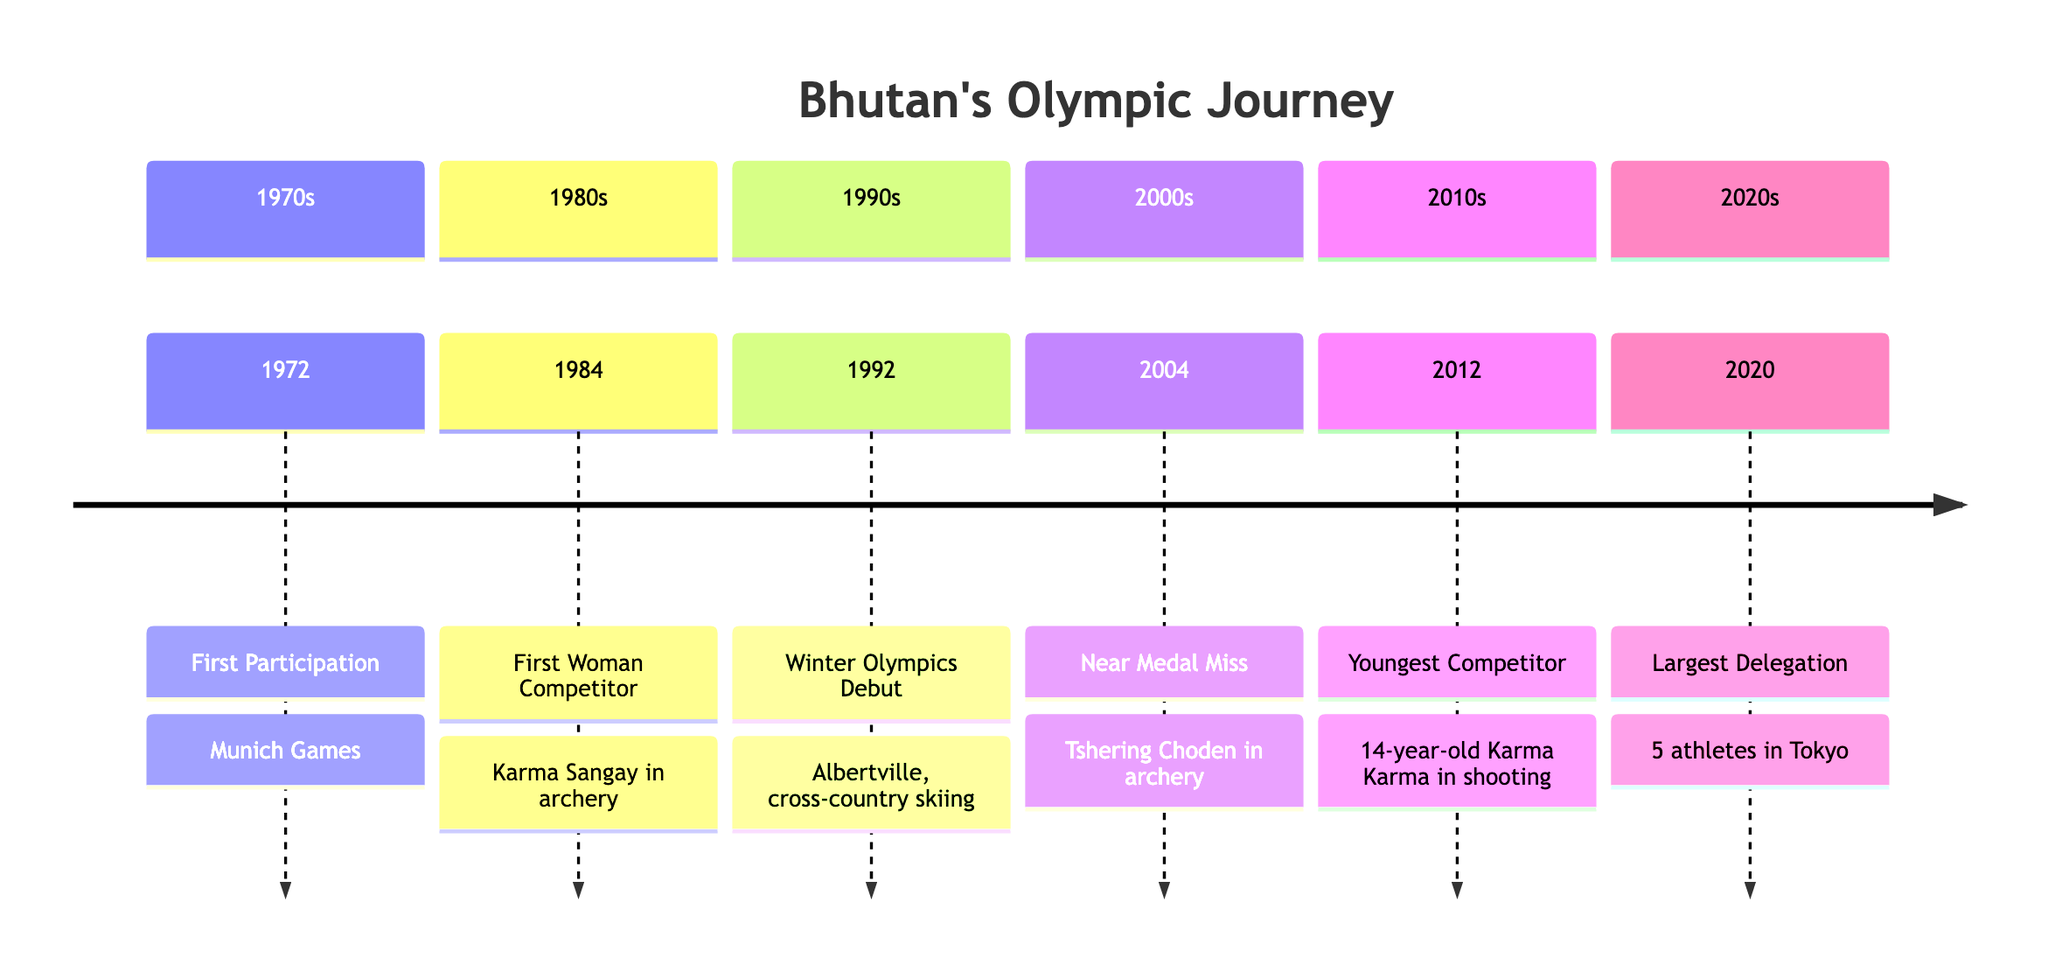what year did Bhutan first participate in the Olympics? The timeline indicates that Bhutan's first participation in the Olympics was in 1972 during the Munich Games.
Answer: 1972 who was Bhutan's first female competitor in the Olympics? The timeline states that Karma Sangay was Bhutan's first female competitor, who participated in archery during the Los Angeles Olympics in 1984.
Answer: Karma Sangay in which year did Bhutan debut at the Winter Olympics? The timeline shows that Bhutan made its debut in the Winter Olympics in 1992 at Albertville.
Answer: 1992 how many athletes represented Bhutan at the 2020 Tokyo Olympics? According to the timeline, Bhutan sent five athletes to compete in various sports during the Tokyo Olympics in 2020.
Answer: 5 what notable event occurred for Bhutan in the year 2004? The timeline highlights that in 2004, Tshering Choden, an archer, reached the quarter-finals in Athens, which was Bhutan's first Olympic medal near miss.
Answer: First Olympic Medal Near Miss which year marked the participation of Bhutan's youngest competitor? The timeline indicates that the youngest competitor for Bhutan, 14-year-old Karma Karma, participated in the shooting event during the London Olympics in 2012.
Answer: 2012 what sport did Bhutan's first female competitor participate in? The timeline details that Bhutan's first female competitor, Karma Sangay, competed in archery during the Los Angeles Olympics in 1984.
Answer: Archery what is the significance of the year 2020 in Bhutan's Olympic journey? The timeline states that in 2020, Bhutan sent its largest delegation of five athletes to the Tokyo Olympics, marking significant progress in the country's Olympic history.
Answer: Largest Delegation 